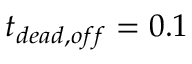Convert formula to latex. <formula><loc_0><loc_0><loc_500><loc_500>t _ { d e a d , o f f } = 0 . 1</formula> 